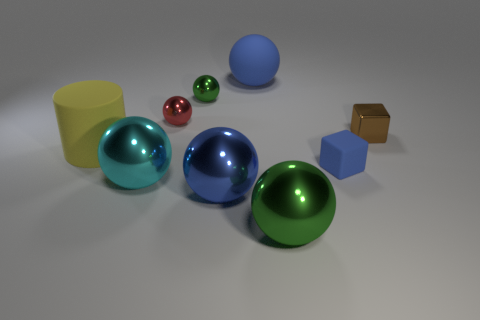There is a big green ball; how many large blue metallic balls are left of it?
Provide a succinct answer. 1. There is another ball that is the same color as the rubber ball; what is its material?
Keep it short and to the point. Metal. How many big objects are spheres or yellow rubber things?
Keep it short and to the point. 5. What is the shape of the rubber object behind the small metallic block?
Offer a very short reply. Sphere. Are there any metal objects that have the same color as the small metallic block?
Your response must be concise. No. There is a green ball that is behind the matte cylinder; does it have the same size as the blue rubber thing that is behind the blue rubber block?
Provide a short and direct response. No. Are there more things to the right of the big cylinder than large matte spheres that are to the left of the large cyan object?
Ensure brevity in your answer.  Yes. Is there a tiny cylinder made of the same material as the small red sphere?
Ensure brevity in your answer.  No. Is the tiny rubber object the same color as the tiny shiny block?
Provide a succinct answer. No. What is the material of the thing that is to the left of the large green ball and to the right of the large blue metal ball?
Your response must be concise. Rubber. 